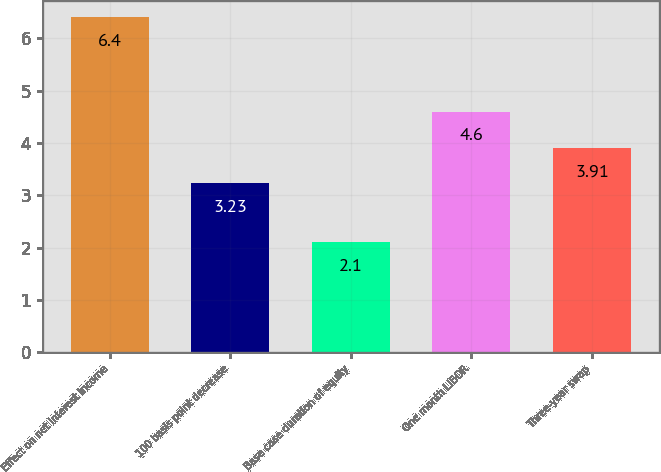Convert chart. <chart><loc_0><loc_0><loc_500><loc_500><bar_chart><fcel>Effect on net interest income<fcel>100 basis point decrease<fcel>Base case duration of equity<fcel>One month LIBOR<fcel>Three-year swap<nl><fcel>6.4<fcel>3.23<fcel>2.1<fcel>4.6<fcel>3.91<nl></chart> 